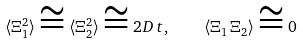<formula> <loc_0><loc_0><loc_500><loc_500>\langle \Xi _ { 1 } ^ { 2 } \rangle \cong \langle \Xi _ { 2 } ^ { 2 } \rangle \cong 2 D \, t , \quad \langle \Xi _ { 1 } \, \Xi _ { 2 } \rangle \cong 0</formula> 